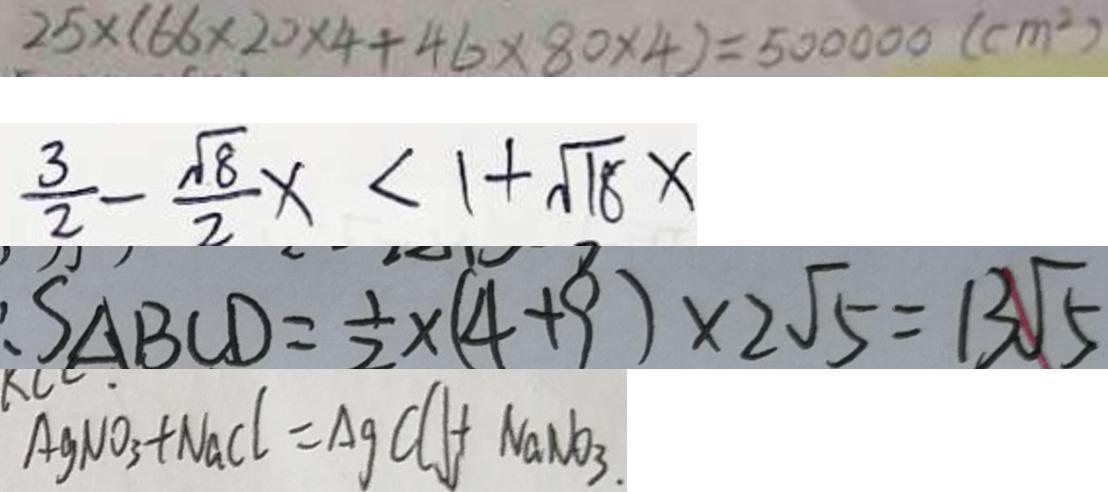<formula> <loc_0><loc_0><loc_500><loc_500>2 5 \times ( 6 6 \times 2 0 \times 4 + 4 6 \times 8 0 \times 4 ) = 5 0 0 0 0 0 ( c m ^ { 2 } ) 
 \frac { 3 } { 2 } - \frac { \sqrt { 8 } } { 2 } x < 1 + \sqrt { 1 8 } x 
 S _ { \Delta B C D } = \frac { 1 } { 2 } \times ( 4 + 9 ) \times 2 \sqrt { 5 } = 1 3 \sqrt { 5 } 
 A g N O _ { 3 } + N a C l = A g C l \downarrow + N a N O _ { 3 } .</formula> 